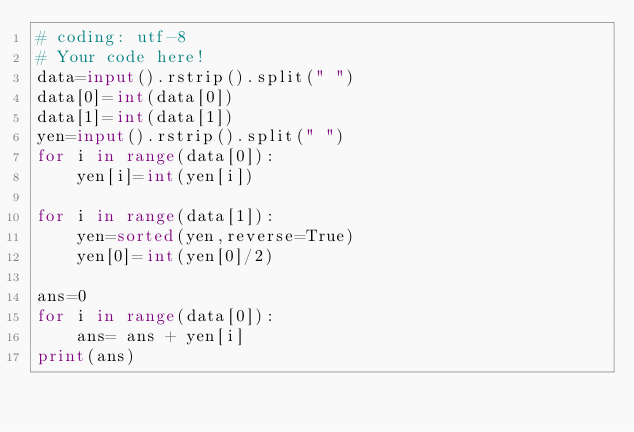<code> <loc_0><loc_0><loc_500><loc_500><_Python_># coding: utf-8
# Your code here!
data=input().rstrip().split(" ")
data[0]=int(data[0])
data[1]=int(data[1])
yen=input().rstrip().split(" ")
for i in range(data[0]):
    yen[i]=int(yen[i])
    
for i in range(data[1]):
    yen=sorted(yen,reverse=True)
    yen[0]=int(yen[0]/2)

ans=0
for i in range(data[0]):
    ans= ans + yen[i]
print(ans)</code> 